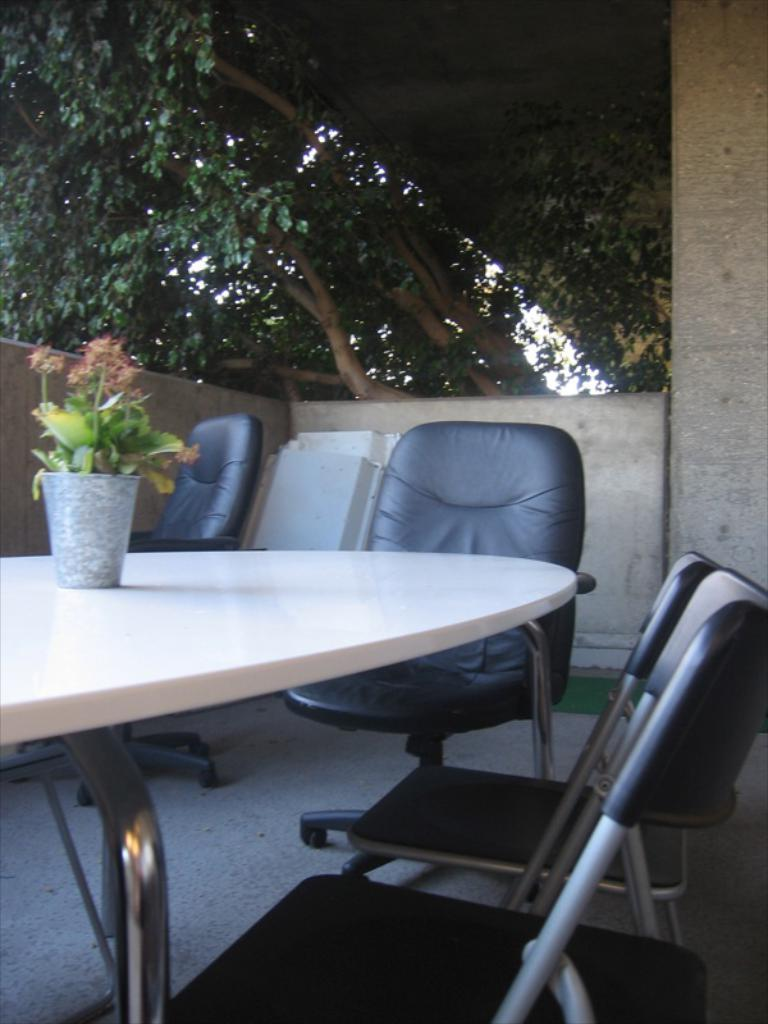What type of outdoor space is shown in the image? The image depicts a balcony. What furniture is visible on the balcony? There are multiple chairs on the balcony. Is there any furniture for placing items on the balcony? Yes, there is a table on the balcony. What can be found on the table? A house plant is present on the table. What can be seen in the background of the image? Trees are visible near the balcony. What type of apple is being used as a cloth on the table in the image? There is no apple or cloth present on the table in the image; only a house plant is visible. 